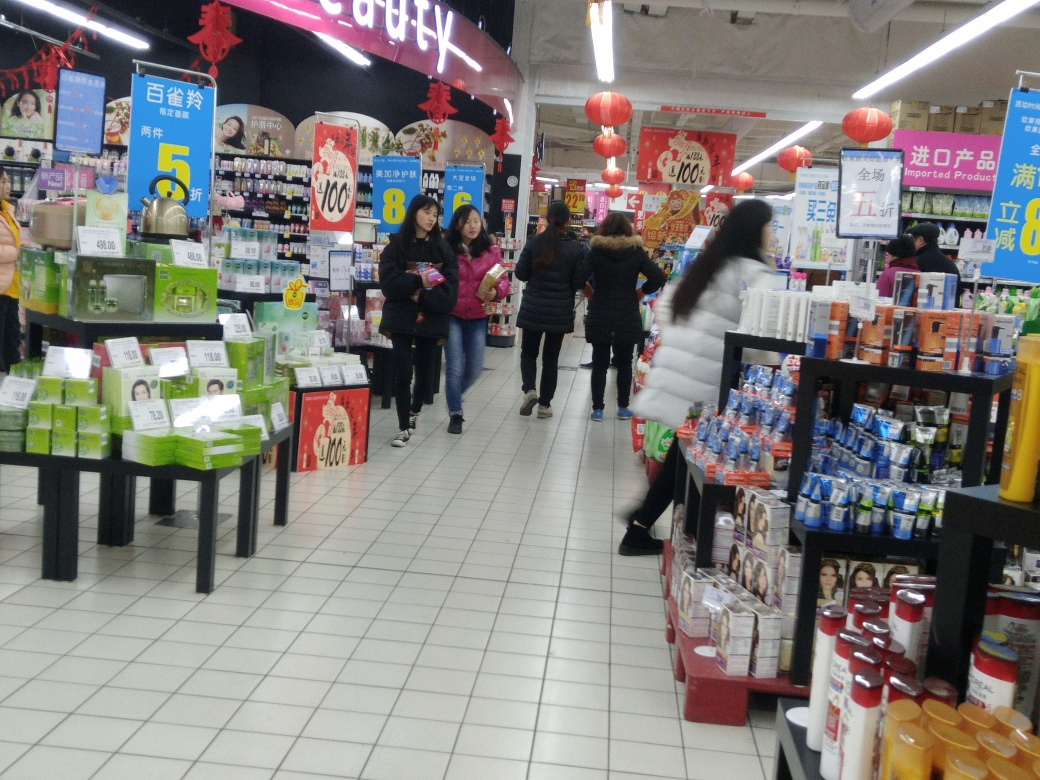Considering the decor, what could be the possible occasion here? The red lanterns hanging from the ceiling are often associated with Chinese cultural festivities, such as Chinese New Year. These decorations lend a festive and celebratory vibe to the supermarket. The presence of special deals and promotions, as indicated by the signage, also suggests that the store is capitalizing on the holiday spirit to attract shoppers. 